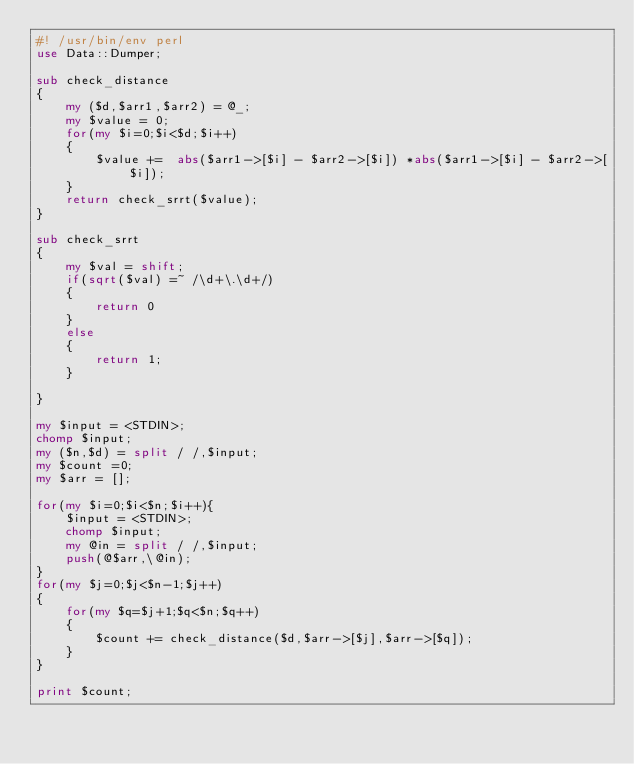<code> <loc_0><loc_0><loc_500><loc_500><_Perl_>#! /usr/bin/env perl
use Data::Dumper;

sub check_distance
{
    my ($d,$arr1,$arr2) = @_;
    my $value = 0;
    for(my $i=0;$i<$d;$i++)
    {
        $value +=  abs($arr1->[$i] - $arr2->[$i]) *abs($arr1->[$i] - $arr2->[$i]);
    }
    return check_srrt($value);
}

sub check_srrt
{ 
    my $val = shift;
    if(sqrt($val) =~ /\d+\.\d+/)
    {
        return 0
    }
    else
    {
        return 1;
    }

}

my $input = <STDIN>;
chomp $input;
my ($n,$d) = split / /,$input;
my $count =0;
my $arr = [];

for(my $i=0;$i<$n;$i++){
    $input = <STDIN>;
    chomp $input;
    my @in = split / /,$input;
    push(@$arr,\@in);
}
for(my $j=0;$j<$n-1;$j++)
{
    for(my $q=$j+1;$q<$n;$q++)
    {
        $count += check_distance($d,$arr->[$j],$arr->[$q]);
    }
}

print $count;
</code> 